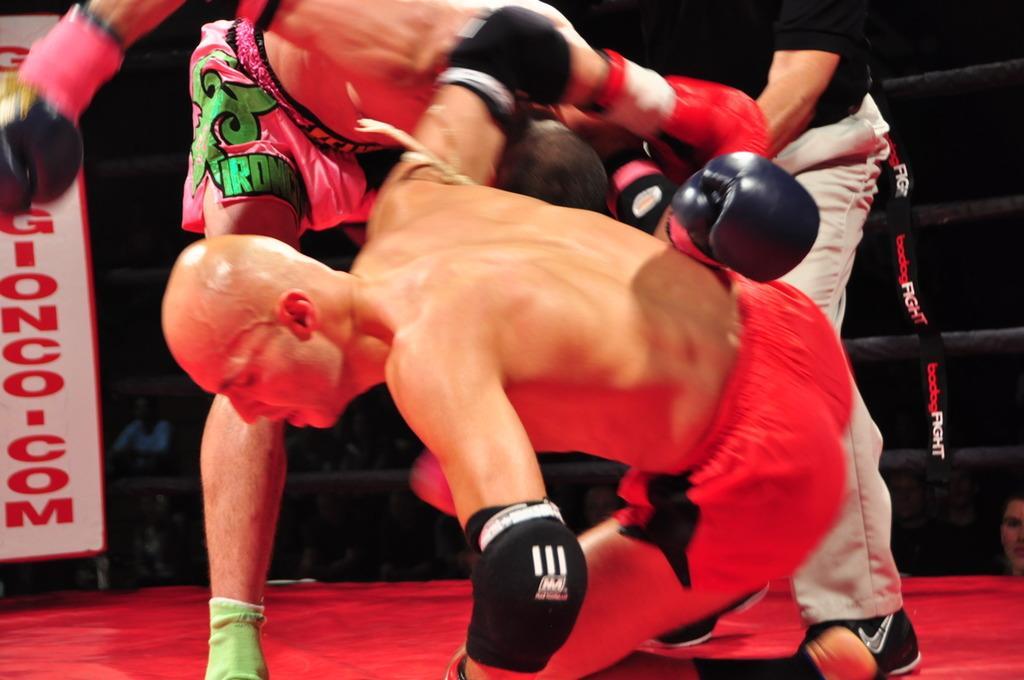Describe this image in one or two sentences. In this image, there are three people in a boxing ring. On the left side of the image, I can see a banner. In the background, there are group of people. 